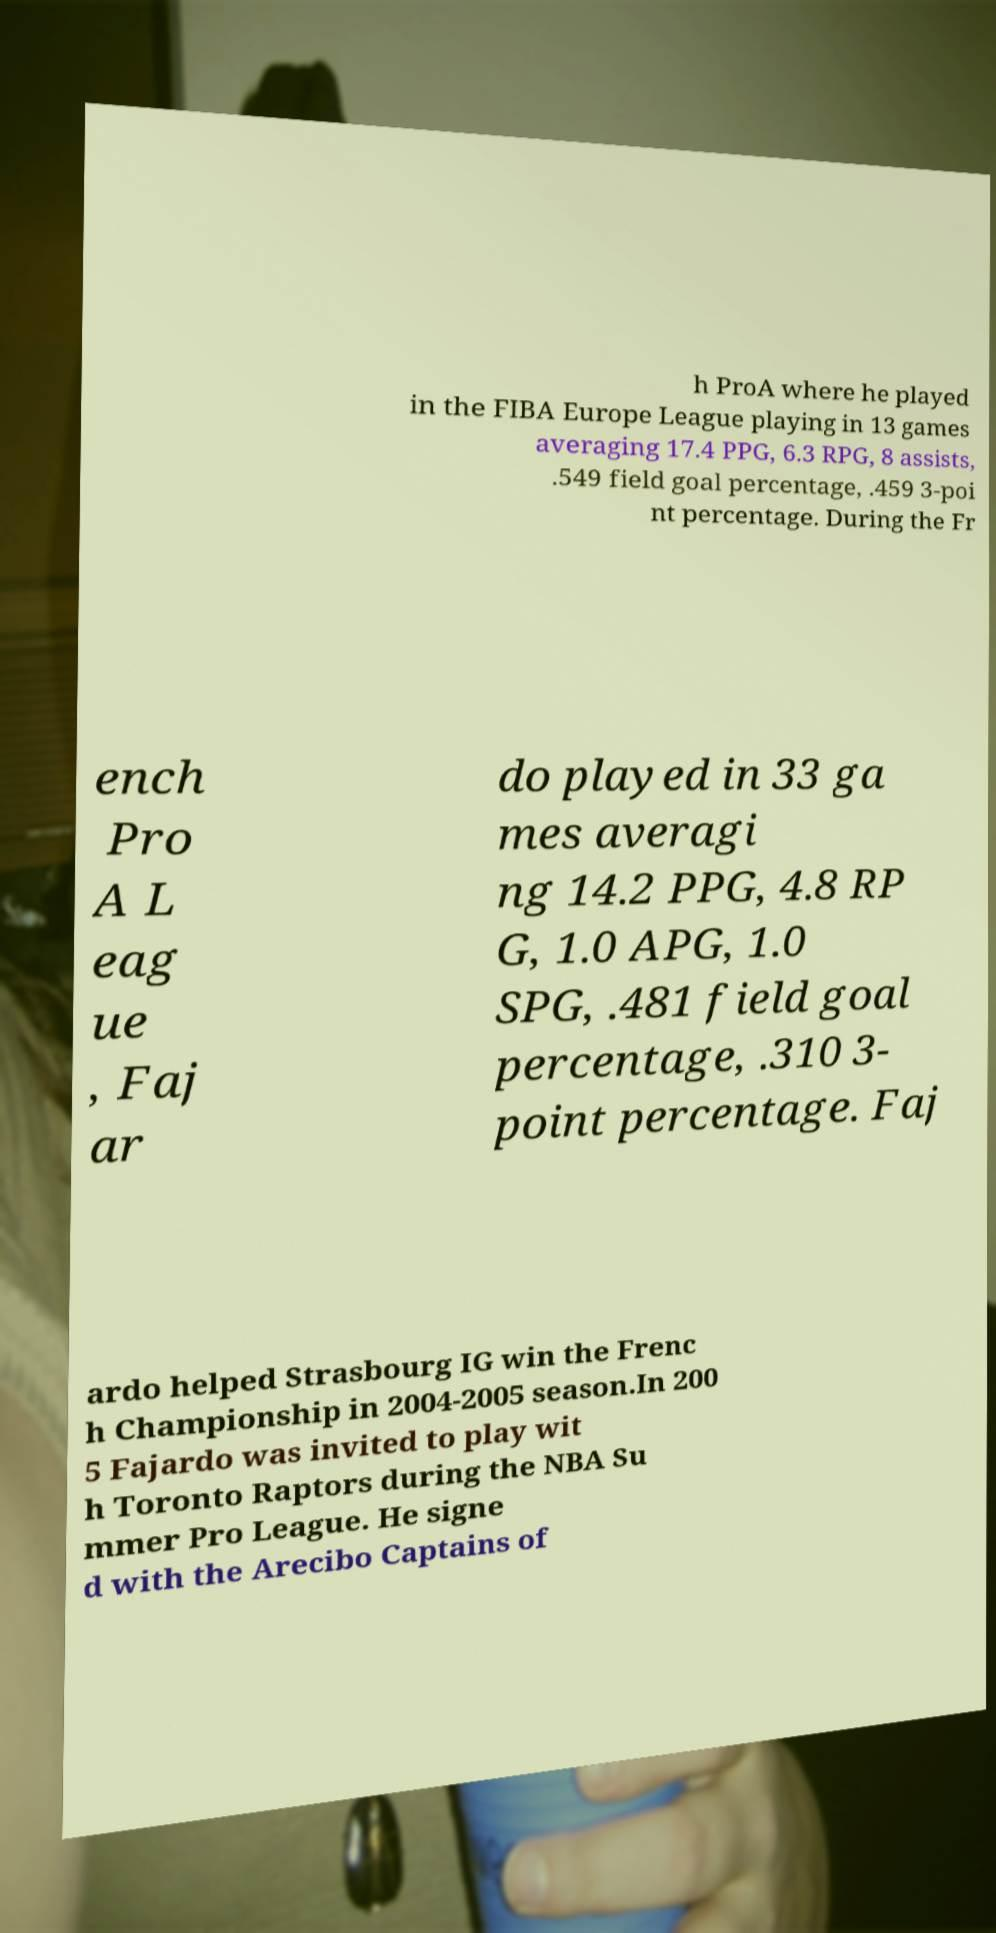For documentation purposes, I need the text within this image transcribed. Could you provide that? h ProA where he played in the FIBA Europe League playing in 13 games averaging 17.4 PPG, 6.3 RPG, 8 assists, .549 field goal percentage, .459 3-poi nt percentage. During the Fr ench Pro A L eag ue , Faj ar do played in 33 ga mes averagi ng 14.2 PPG, 4.8 RP G, 1.0 APG, 1.0 SPG, .481 field goal percentage, .310 3- point percentage. Faj ardo helped Strasbourg IG win the Frenc h Championship in 2004-2005 season.In 200 5 Fajardo was invited to play wit h Toronto Raptors during the NBA Su mmer Pro League. He signe d with the Arecibo Captains of 